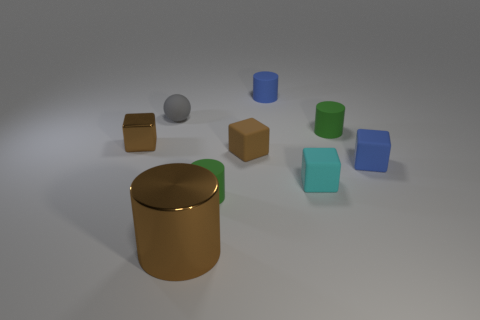There is a tiny blue thing that is the same shape as the big brown metallic object; what is it made of?
Provide a succinct answer. Rubber. Does the gray sphere that is left of the tiny cyan object have the same material as the brown thing that is in front of the blue block?
Make the answer very short. No. Is there a metal block of the same color as the metallic cylinder?
Give a very brief answer. Yes. Is the color of the tiny cylinder that is in front of the small blue rubber block the same as the small shiny cube that is behind the brown matte thing?
Provide a succinct answer. No. There is a brown object in front of the small cyan matte object; what is it made of?
Your answer should be very brief. Metal. What is the color of the cube that is made of the same material as the large cylinder?
Offer a terse response. Brown. How many blue matte objects are the same size as the brown cylinder?
Your response must be concise. 0. Is the size of the green thing that is behind the cyan matte object the same as the rubber ball?
Make the answer very short. Yes. The rubber object that is both in front of the gray rubber ball and behind the small shiny block has what shape?
Offer a terse response. Cylinder. Are there any green matte things to the left of the brown rubber block?
Your answer should be very brief. Yes. 